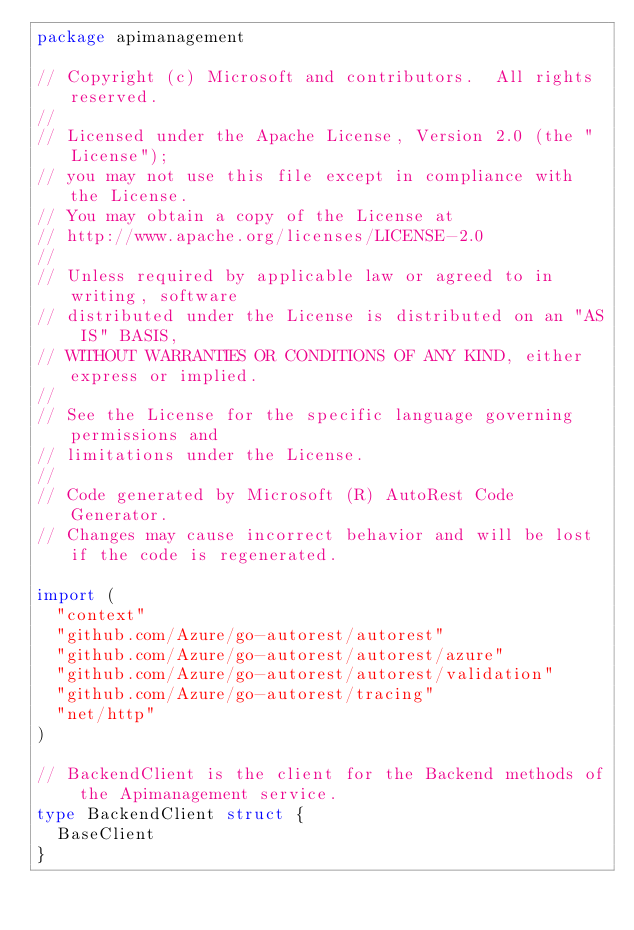Convert code to text. <code><loc_0><loc_0><loc_500><loc_500><_Go_>package apimanagement

// Copyright (c) Microsoft and contributors.  All rights reserved.
//
// Licensed under the Apache License, Version 2.0 (the "License");
// you may not use this file except in compliance with the License.
// You may obtain a copy of the License at
// http://www.apache.org/licenses/LICENSE-2.0
//
// Unless required by applicable law or agreed to in writing, software
// distributed under the License is distributed on an "AS IS" BASIS,
// WITHOUT WARRANTIES OR CONDITIONS OF ANY KIND, either express or implied.
//
// See the License for the specific language governing permissions and
// limitations under the License.
//
// Code generated by Microsoft (R) AutoRest Code Generator.
// Changes may cause incorrect behavior and will be lost if the code is regenerated.

import (
	"context"
	"github.com/Azure/go-autorest/autorest"
	"github.com/Azure/go-autorest/autorest/azure"
	"github.com/Azure/go-autorest/autorest/validation"
	"github.com/Azure/go-autorest/tracing"
	"net/http"
)

// BackendClient is the client for the Backend methods of the Apimanagement service.
type BackendClient struct {
	BaseClient
}
</code> 